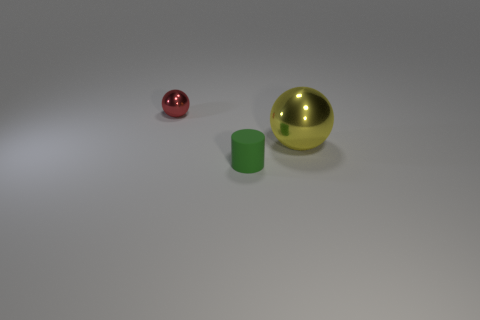Add 1 red metallic spheres. How many objects exist? 4 Subtract all spheres. How many objects are left? 1 Subtract all brown cylinders. Subtract all cyan spheres. How many cylinders are left? 1 Subtract all tiny cubes. Subtract all red spheres. How many objects are left? 2 Add 1 tiny cylinders. How many tiny cylinders are left? 2 Add 1 big metal balls. How many big metal balls exist? 2 Subtract 0 gray cylinders. How many objects are left? 3 